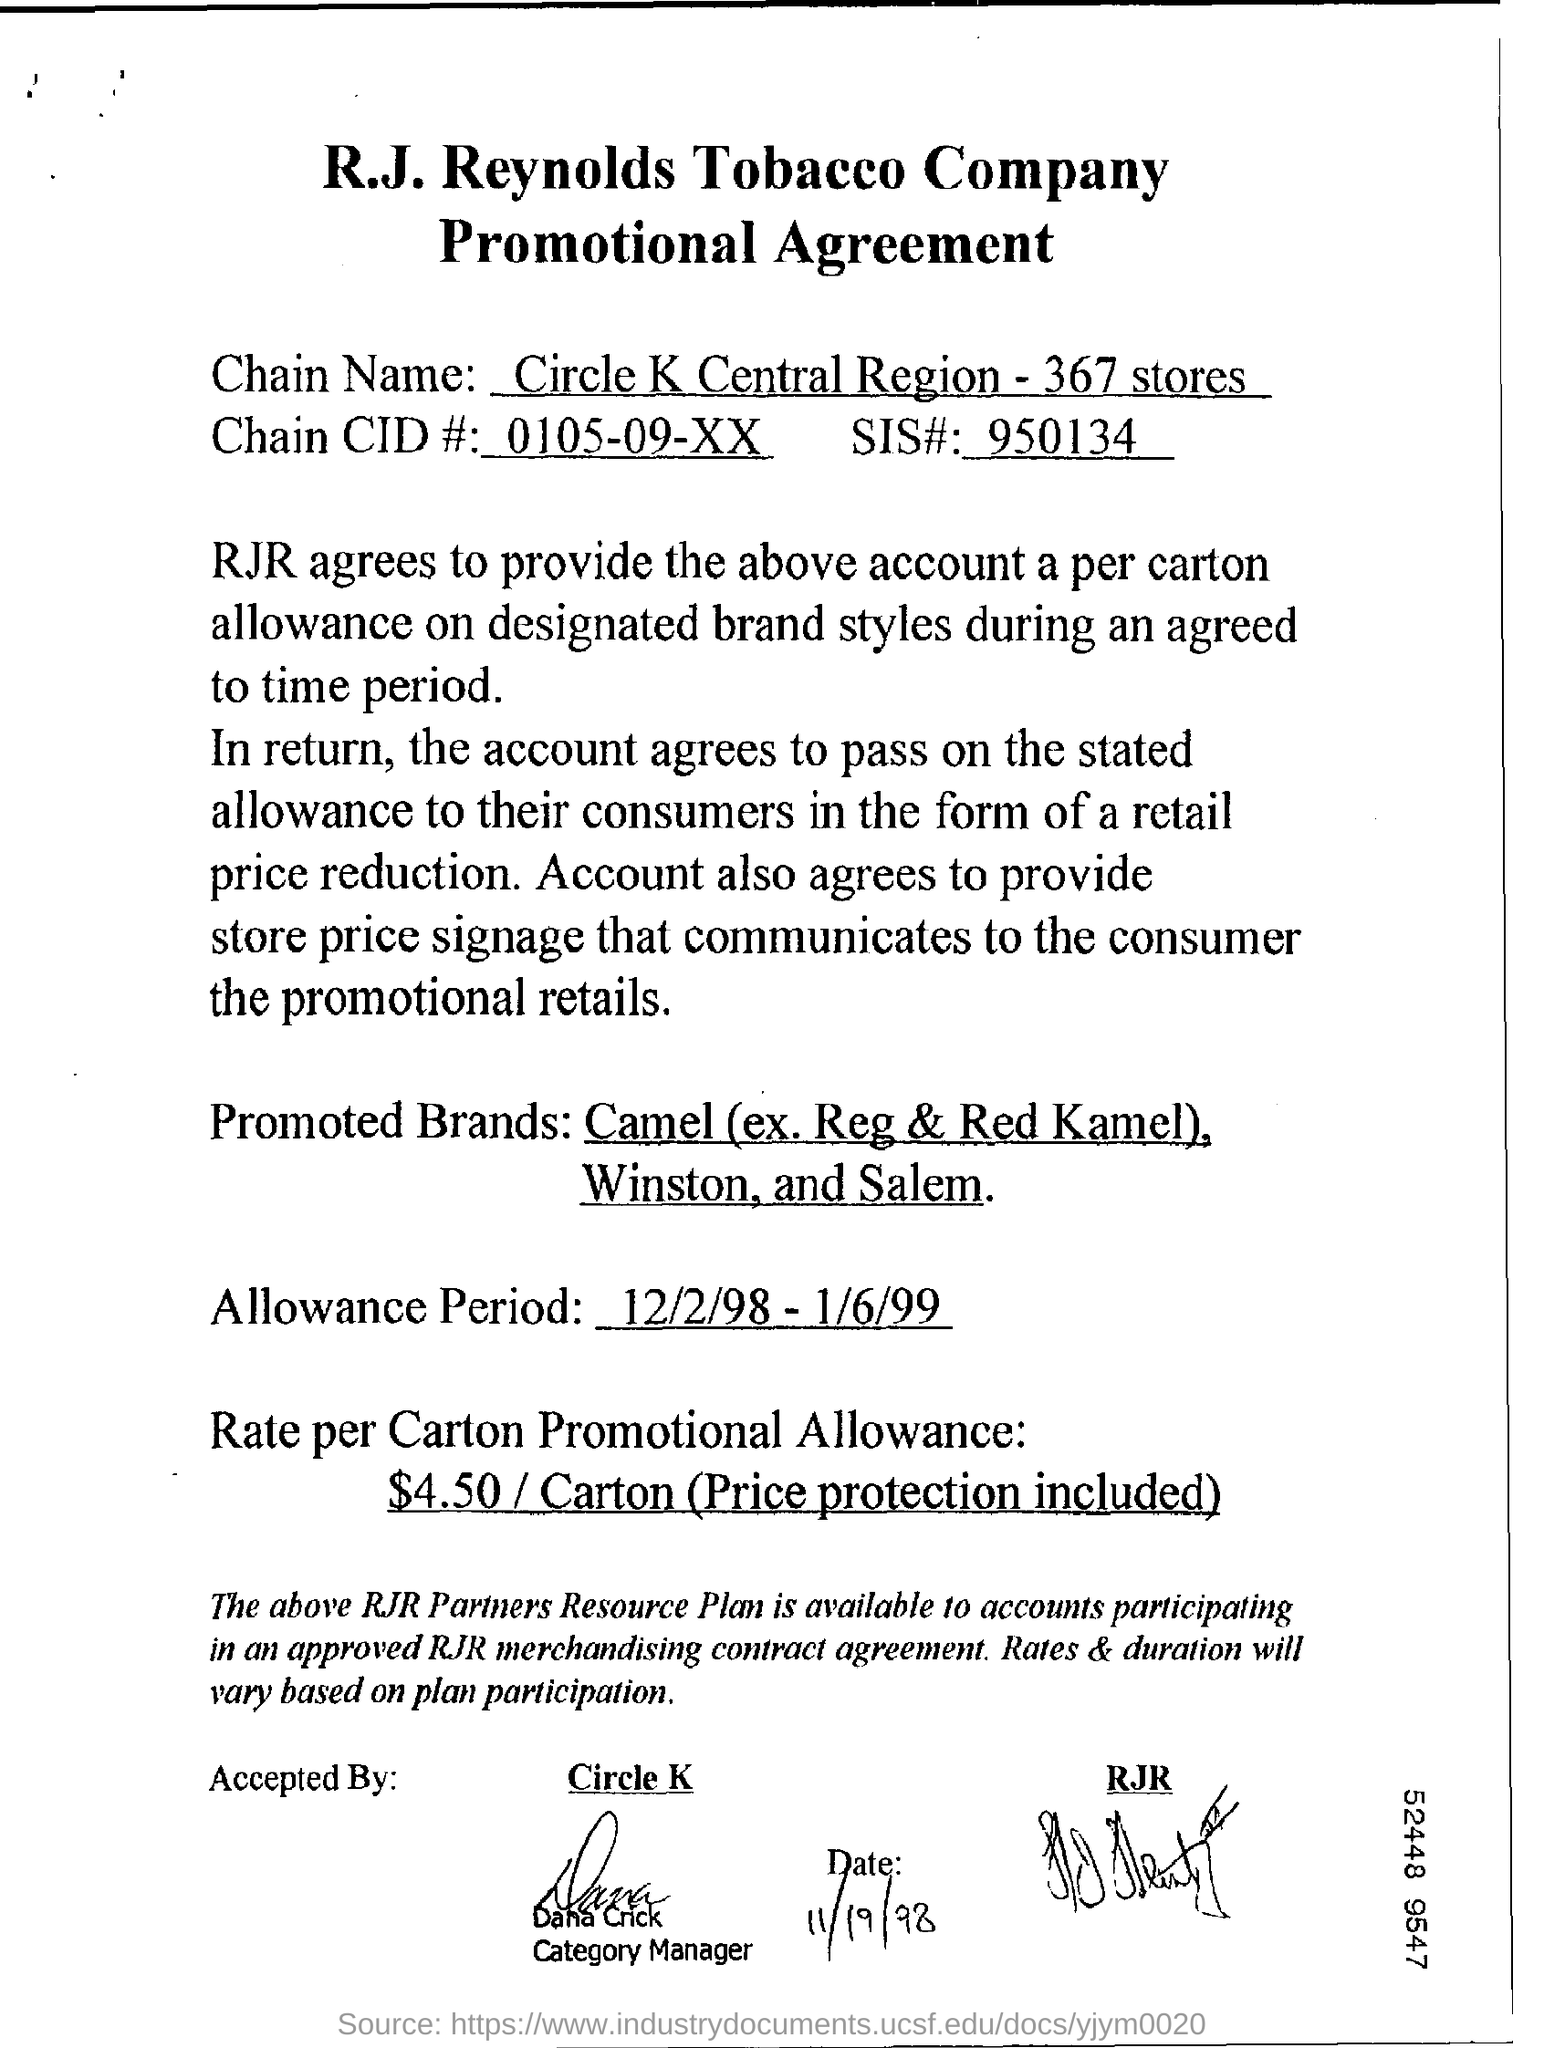What is the chain name and how many stores are involved in this promotion? The chain participating in the promotion is Circle K Central Region, and there are 367 stores involved.  Is there any additional support provided as part of this agreement? Yes, the stores agree to provide price signage that communicates the promotional details to the consumers, in addition to passing on the carton allowance to them. 